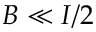Convert formula to latex. <formula><loc_0><loc_0><loc_500><loc_500>B \ll I / 2</formula> 